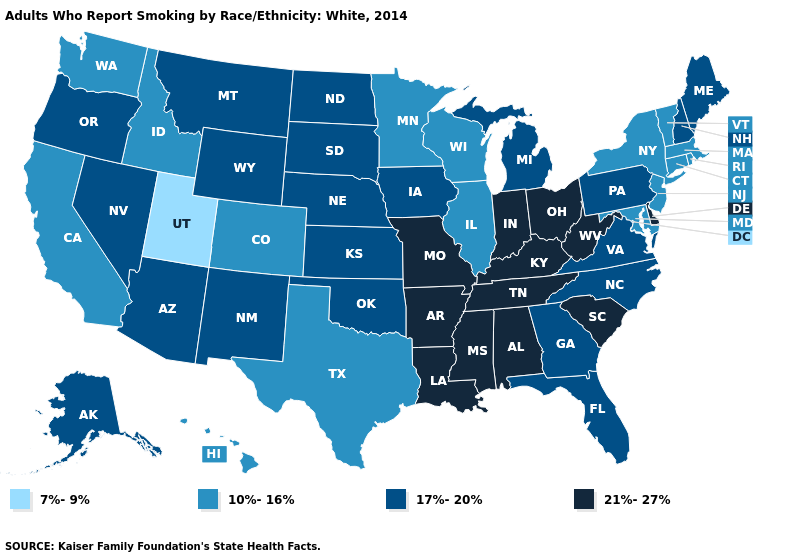Does Kansas have the same value as Iowa?
Short answer required. Yes. Among the states that border Kentucky , does Virginia have the highest value?
Be succinct. No. What is the lowest value in states that border Washington?
Be succinct. 10%-16%. Name the states that have a value in the range 17%-20%?
Answer briefly. Alaska, Arizona, Florida, Georgia, Iowa, Kansas, Maine, Michigan, Montana, Nebraska, Nevada, New Hampshire, New Mexico, North Carolina, North Dakota, Oklahoma, Oregon, Pennsylvania, South Dakota, Virginia, Wyoming. Name the states that have a value in the range 10%-16%?
Short answer required. California, Colorado, Connecticut, Hawaii, Idaho, Illinois, Maryland, Massachusetts, Minnesota, New Jersey, New York, Rhode Island, Texas, Vermont, Washington, Wisconsin. What is the value of Illinois?
Concise answer only. 10%-16%. Among the states that border Arizona , which have the highest value?
Short answer required. Nevada, New Mexico. Which states have the lowest value in the Northeast?
Keep it brief. Connecticut, Massachusetts, New Jersey, New York, Rhode Island, Vermont. What is the value of Arkansas?
Concise answer only. 21%-27%. What is the highest value in the USA?
Quick response, please. 21%-27%. What is the value of New Jersey?
Keep it brief. 10%-16%. Does Minnesota have a lower value than Alabama?
Keep it brief. Yes. What is the lowest value in states that border Vermont?
Short answer required. 10%-16%. Which states have the highest value in the USA?
Give a very brief answer. Alabama, Arkansas, Delaware, Indiana, Kentucky, Louisiana, Mississippi, Missouri, Ohio, South Carolina, Tennessee, West Virginia. 